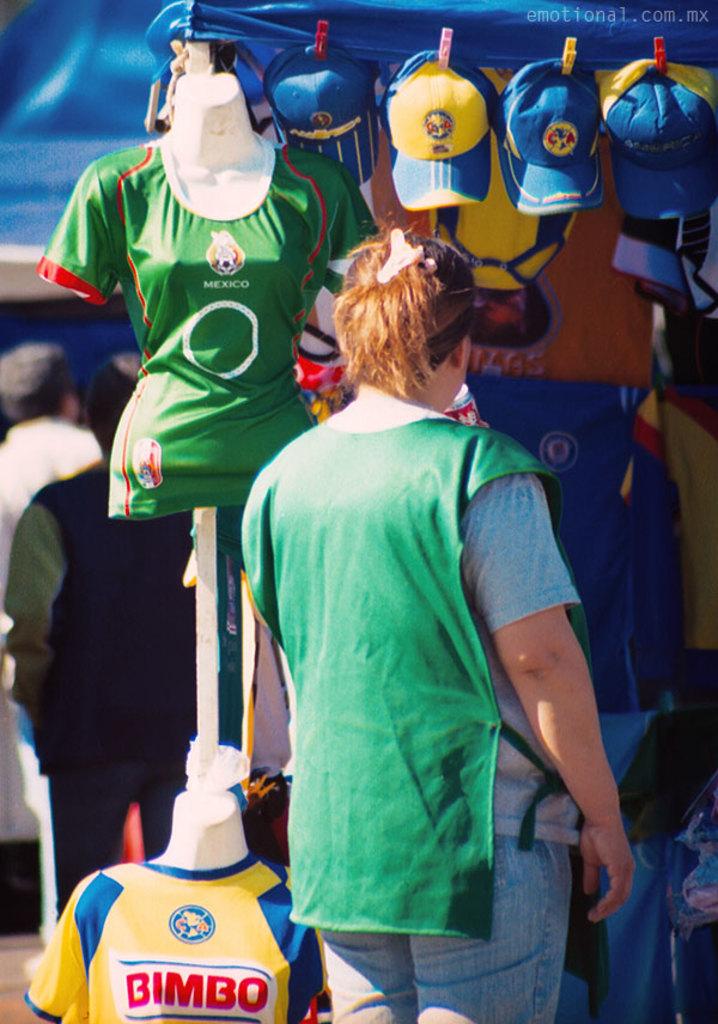What symbol is on the yellow hat?
Your answer should be very brief. Unanswerable. 